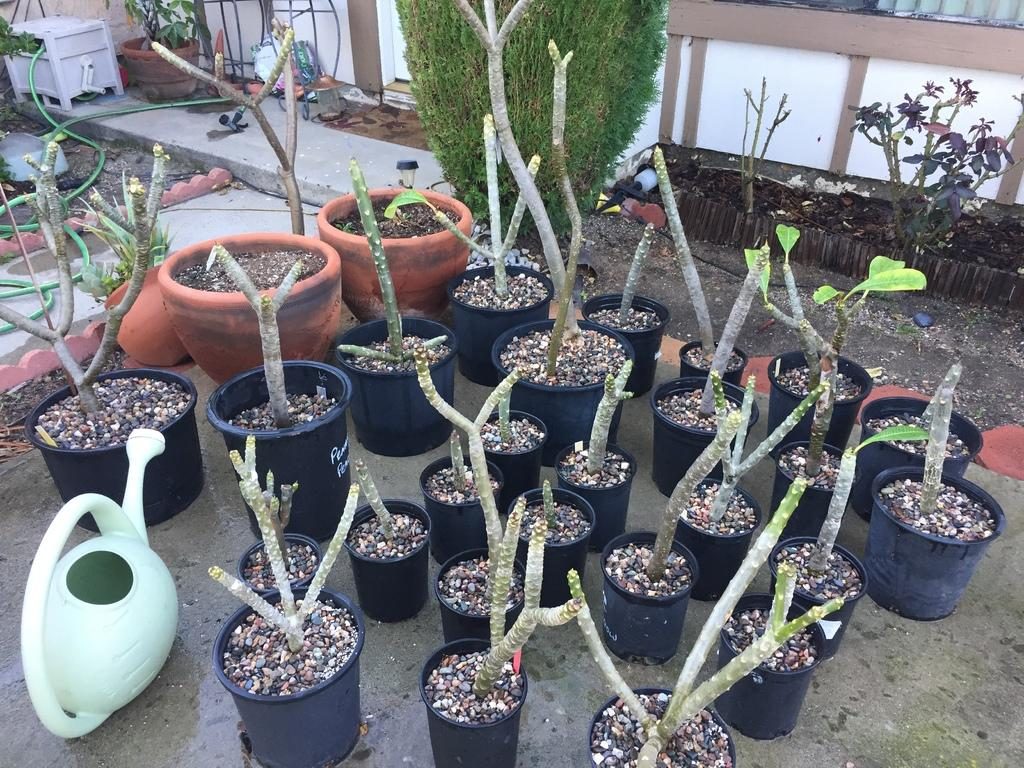What type of living organisms can be seen in the image? Plants can be seen in the image. What color are the plants in the image? The plants are green in color. What is visible in the background of the image? There is a wall visible in the image. What colors are used for the wall in the image? The wall is white and brown in color. How many cows are present in the image? There are no cows present in the image; it features plants and a wall. What type of mark can be seen on the plants in the image? There are no marks visible on the plants in the image. 